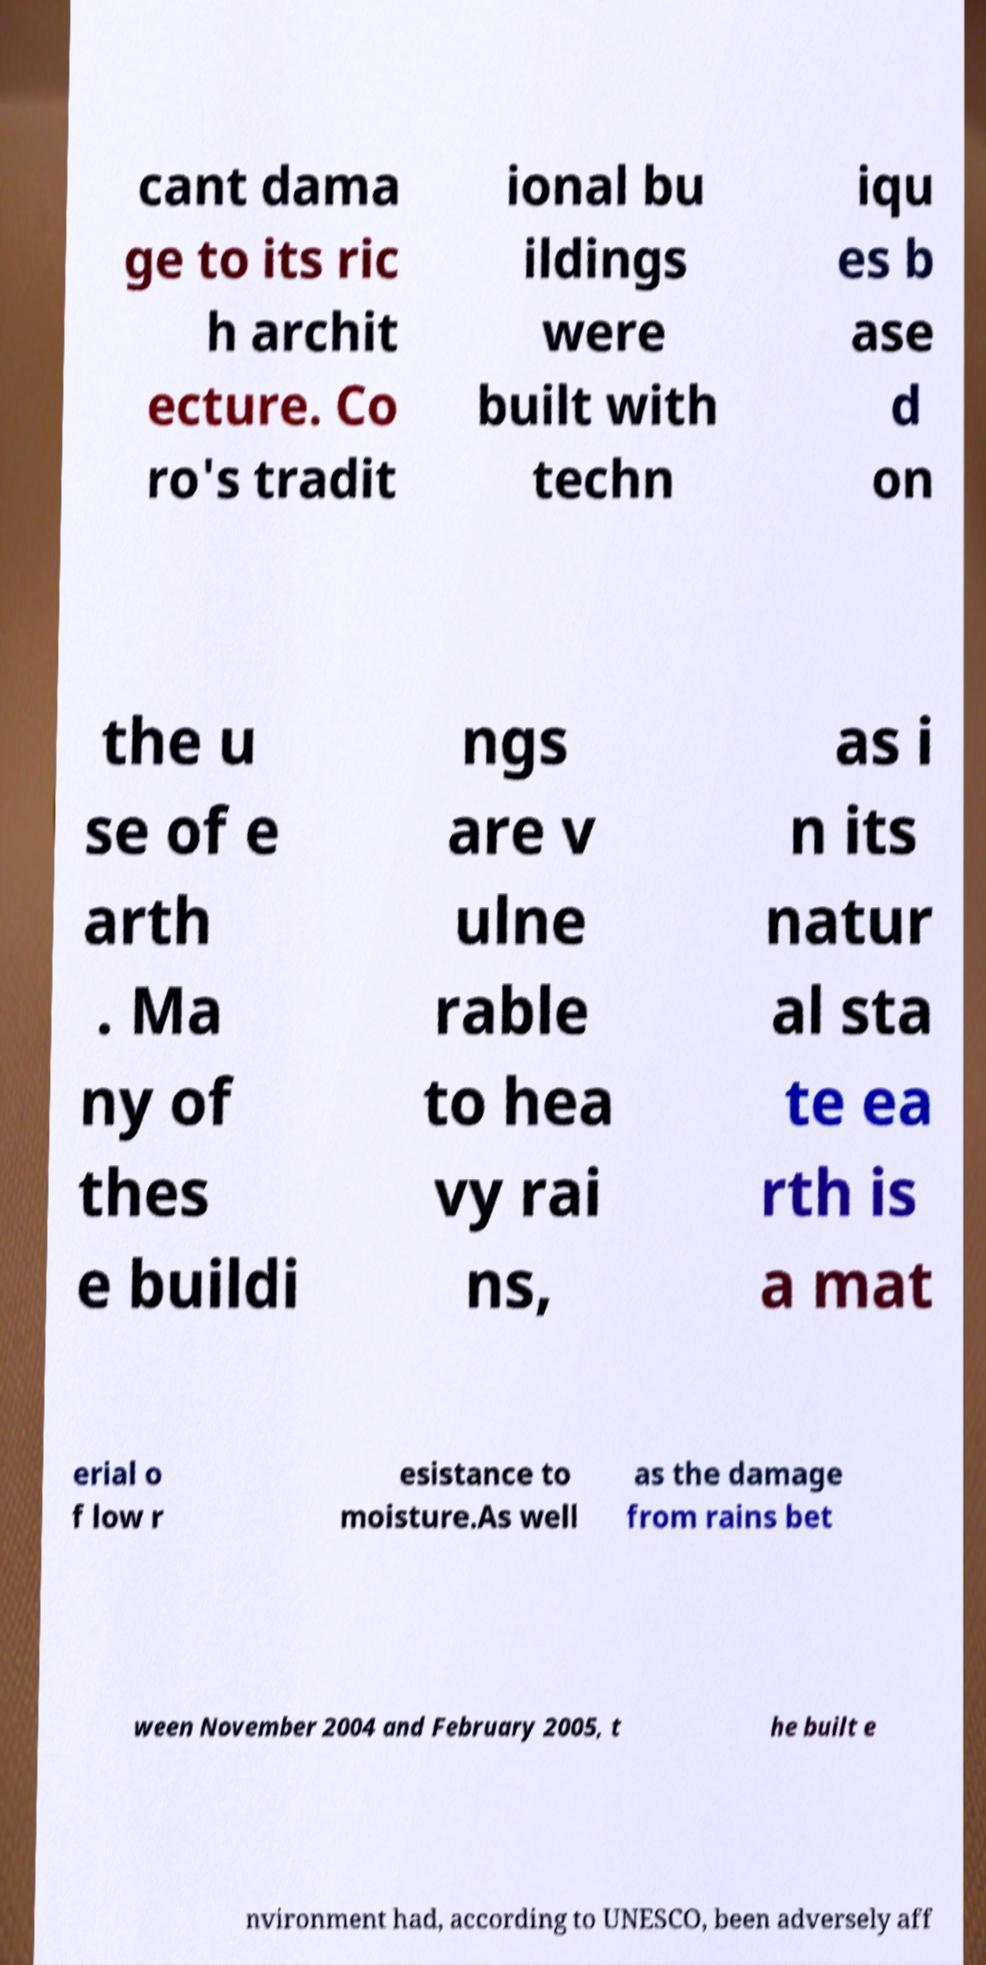Please read and relay the text visible in this image. What does it say? cant dama ge to its ric h archit ecture. Co ro's tradit ional bu ildings were built with techn iqu es b ase d on the u se of e arth . Ma ny of thes e buildi ngs are v ulne rable to hea vy rai ns, as i n its natur al sta te ea rth is a mat erial o f low r esistance to moisture.As well as the damage from rains bet ween November 2004 and February 2005, t he built e nvironment had, according to UNESCO, been adversely aff 